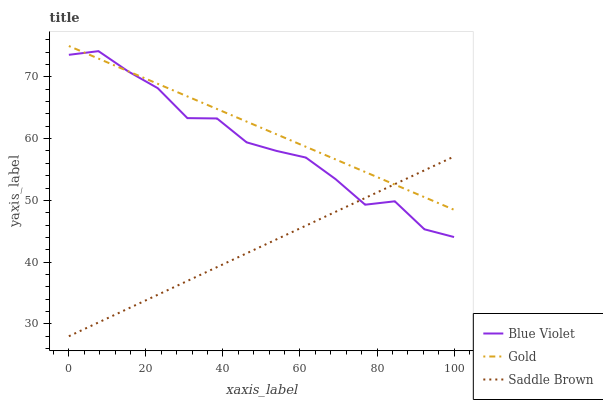Does Blue Violet have the minimum area under the curve?
Answer yes or no. No. Does Blue Violet have the maximum area under the curve?
Answer yes or no. No. Is Blue Violet the smoothest?
Answer yes or no. No. Is Saddle Brown the roughest?
Answer yes or no. No. Does Blue Violet have the lowest value?
Answer yes or no. No. Does Blue Violet have the highest value?
Answer yes or no. No. 